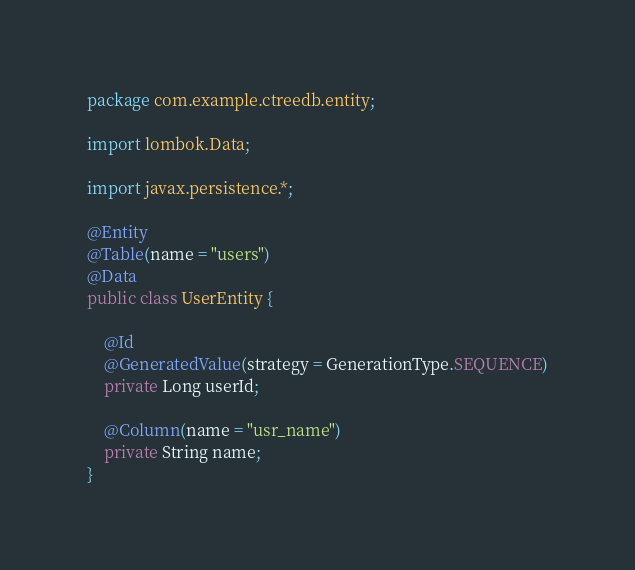Convert code to text. <code><loc_0><loc_0><loc_500><loc_500><_Java_>package com.example.ctreedb.entity;

import lombok.Data;

import javax.persistence.*;

@Entity
@Table(name = "users")
@Data
public class UserEntity {

    @Id
    @GeneratedValue(strategy = GenerationType.SEQUENCE)
    private Long userId;

    @Column(name = "usr_name")
    private String name;
}
</code> 